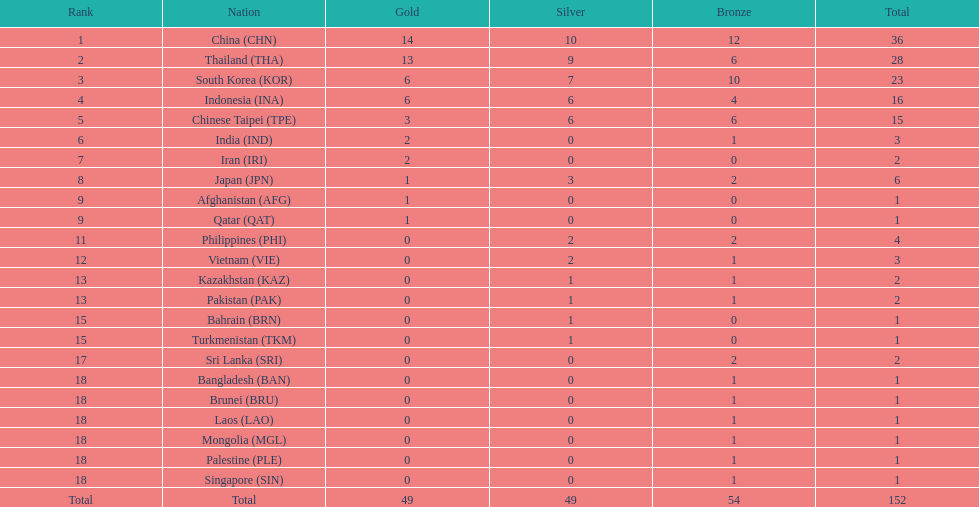What was the total of medals secured by indonesia (ina)? 16. 